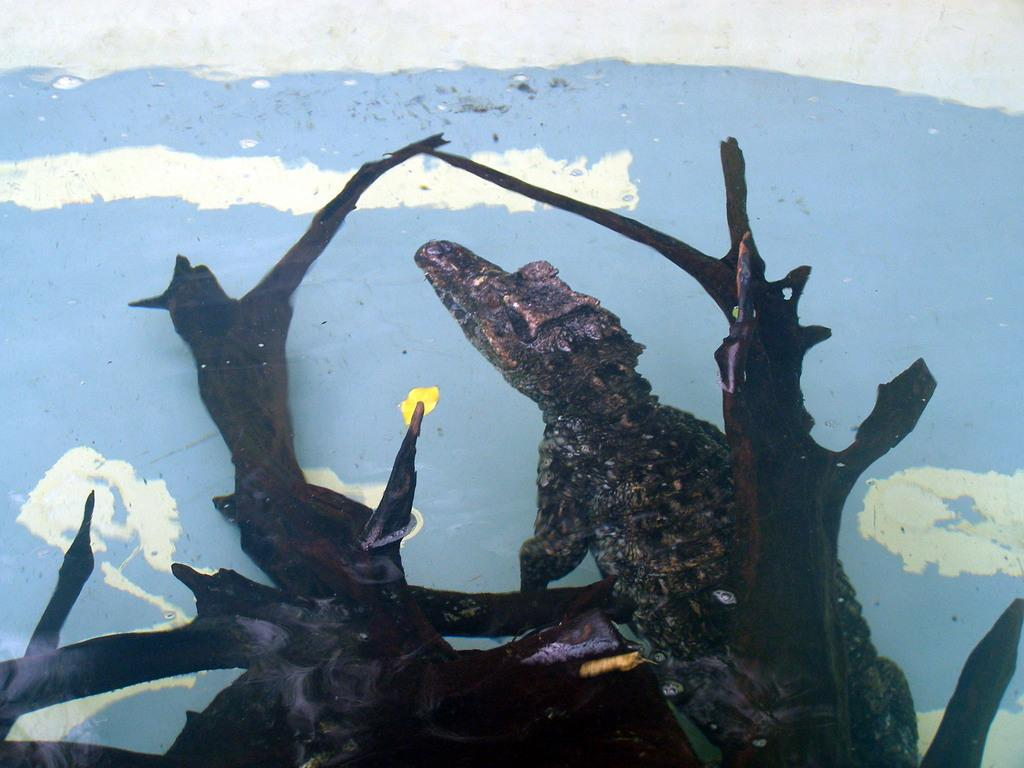What type of animal is in the image? There is a reptile in the image. What is the reptile resting on? The reptile is on a wooden object. What can be seen in the background of the image? There is a wall in the background of the image. What type of street is visible in the image? There is no street visible in the image; it features a reptile on a wooden object with a wall in the background. 